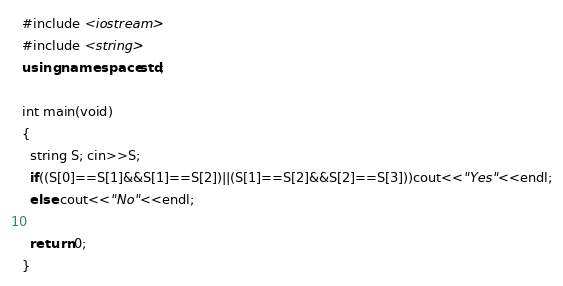Convert code to text. <code><loc_0><loc_0><loc_500><loc_500><_C++_>#include <iostream>
#include <string>
using namespace std;

int main(void)
{
  string S; cin>>S;
  if((S[0]==S[1]&&S[1]==S[2])||(S[1]==S[2]&&S[2]==S[3]))cout<<"Yes"<<endl;
  else cout<<"No"<<endl;

  return 0;
}</code> 